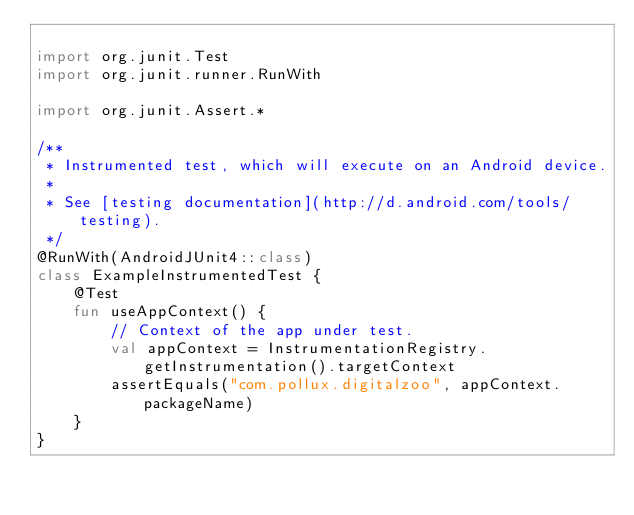<code> <loc_0><loc_0><loc_500><loc_500><_Kotlin_>
import org.junit.Test
import org.junit.runner.RunWith

import org.junit.Assert.*

/**
 * Instrumented test, which will execute on an Android device.
 *
 * See [testing documentation](http://d.android.com/tools/testing).
 */
@RunWith(AndroidJUnit4::class)
class ExampleInstrumentedTest {
    @Test
    fun useAppContext() {
        // Context of the app under test.
        val appContext = InstrumentationRegistry.getInstrumentation().targetContext
        assertEquals("com.pollux.digitalzoo", appContext.packageName)
    }
}</code> 